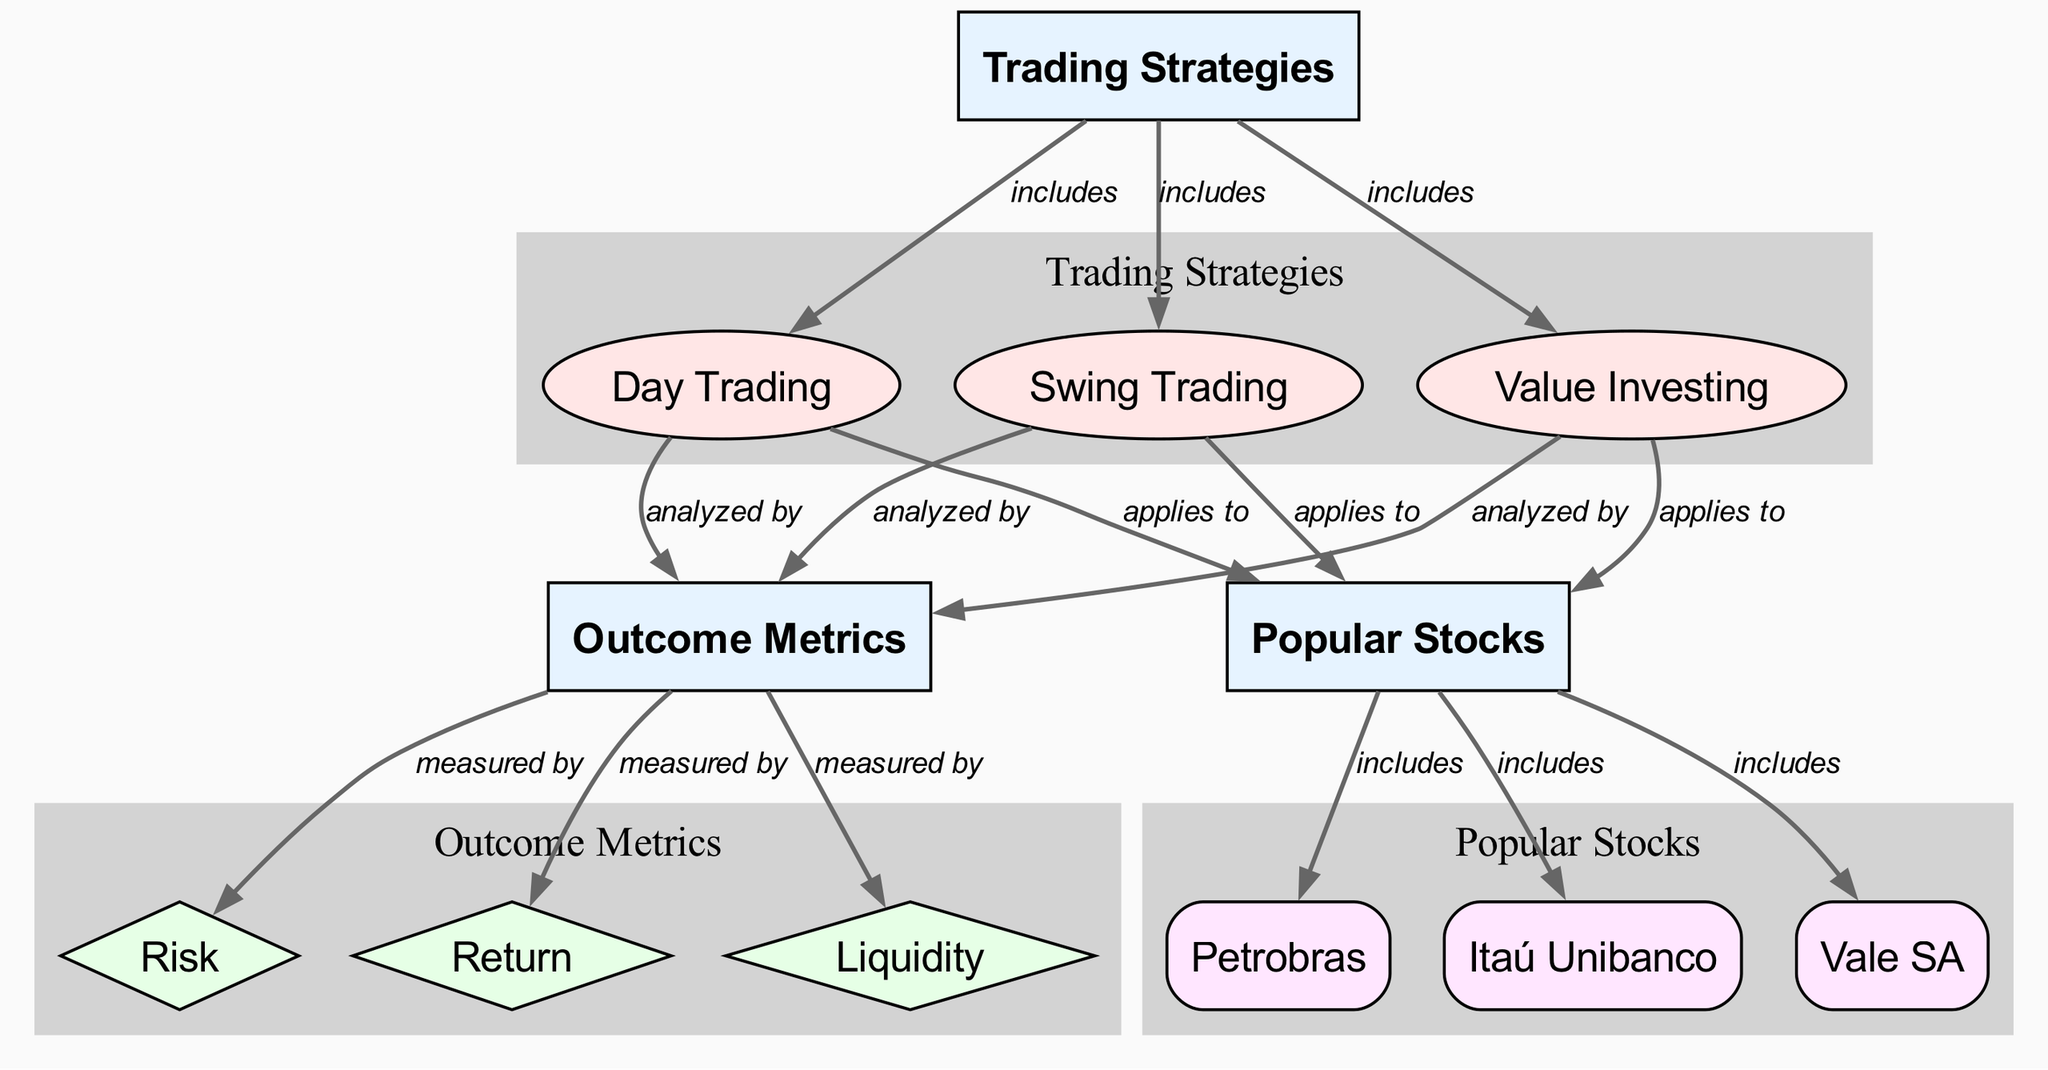What are the three main trading strategies depicted in the diagram? The diagram lists "Value Investing," "Day Trading," and "Swing Trading" as the three main strategies under the "Trading Strategies" category.
Answer: Value Investing, Day Trading, Swing Trading How many outcome metrics are represented in the diagram? The diagram includes three outcome metrics: "Risk," "Return," and "Liquidity" under the "Outcome Metrics" category.
Answer: Three Which trading strategy applies to Petrobras? The edges indicate that "Value Investing," "Day Trading," and "Swing Trading" all apply to popular stocks, including Petrobras.
Answer: Value Investing, Day Trading, Swing Trading Which two metrics are analyzed by the "Swing Trading" strategy? The diagram shows that "Swing Trading" is tied to the outcome metrics of "Risk" and "Return" through the analyzed by relationship.
Answer: Risk, Return Which strategy has the least emphasis in terms of the number of edges? "Day Trading" has a direct relationship with two metrics and is analyzed by three outcome metrics; none of the strategies have significantly fewer edges, but based only on edges, it might seem less emphasized compared to the others as it doesn’t introduce any new connections to popular stocks.
Answer: Day Trading How many popular stocks are mentioned in the diagram? The diagram lists three popular stocks: "Petrobras," "Itaú Unibanco," and "Vale SA" under the "Popular Stocks" category.
Answer: Three What type of relationship connects "Outcome Metrics" to "Risk"? The relationship described in the diagram is labeled as "measured by," which indicates that the "Risk" metric is a way to quantify outcomes for trading strategies.
Answer: Measured by Which trading strategy includes analysis of "Liquidity"? According to the connections drawn in the diagram, "Swing Trading" is one of the strategies that is analyzed by the "Liquidity" metric.
Answer: Swing Trading 